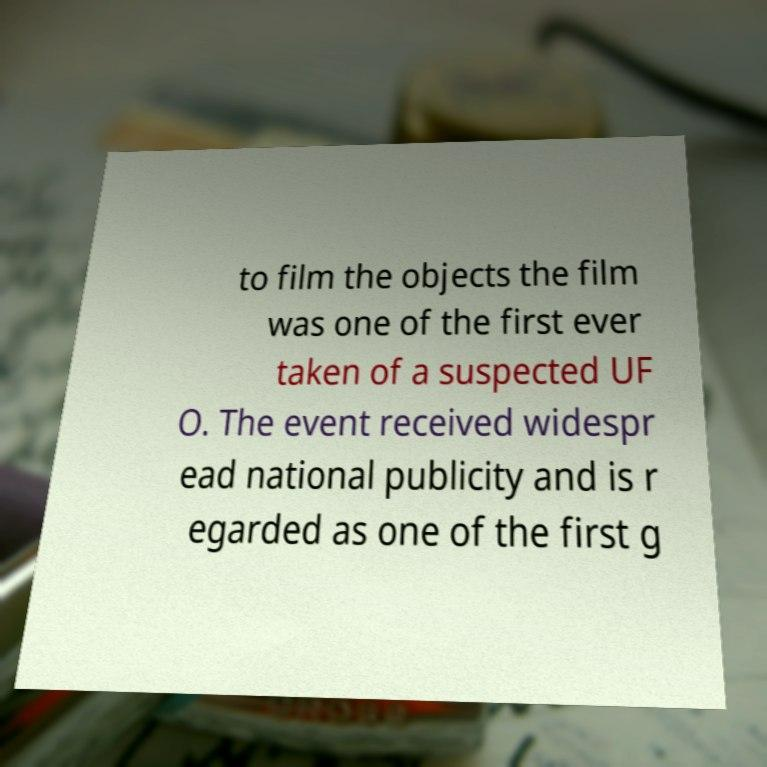What messages or text are displayed in this image? I need them in a readable, typed format. to film the objects the film was one of the first ever taken of a suspected UF O. The event received widespr ead national publicity and is r egarded as one of the first g 